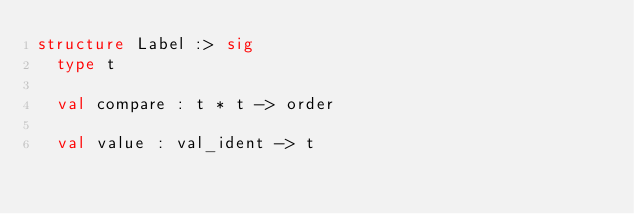Convert code to text. <code><loc_0><loc_0><loc_500><loc_500><_SML_>structure Label :> sig
  type t

  val compare : t * t -> order

  val value : val_ident -> t</code> 